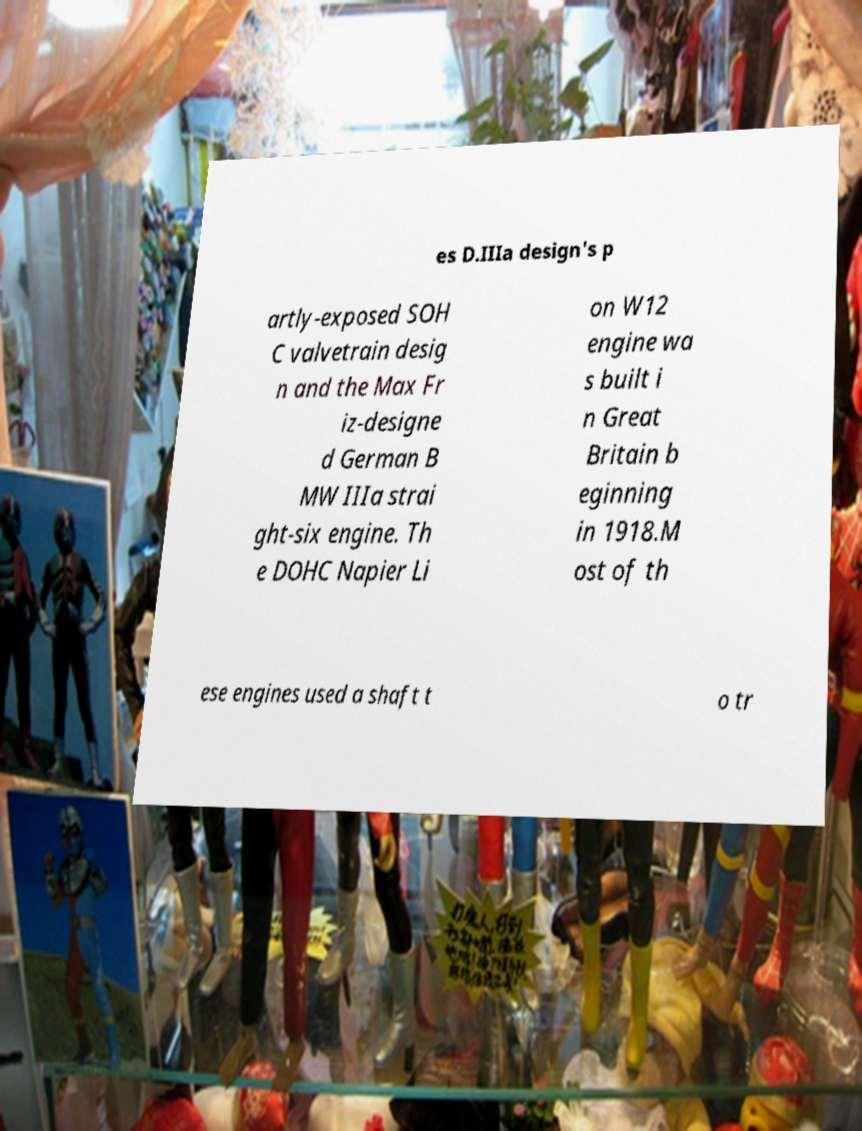Can you read and provide the text displayed in the image?This photo seems to have some interesting text. Can you extract and type it out for me? es D.IIIa design's p artly-exposed SOH C valvetrain desig n and the Max Fr iz-designe d German B MW IIIa strai ght-six engine. Th e DOHC Napier Li on W12 engine wa s built i n Great Britain b eginning in 1918.M ost of th ese engines used a shaft t o tr 